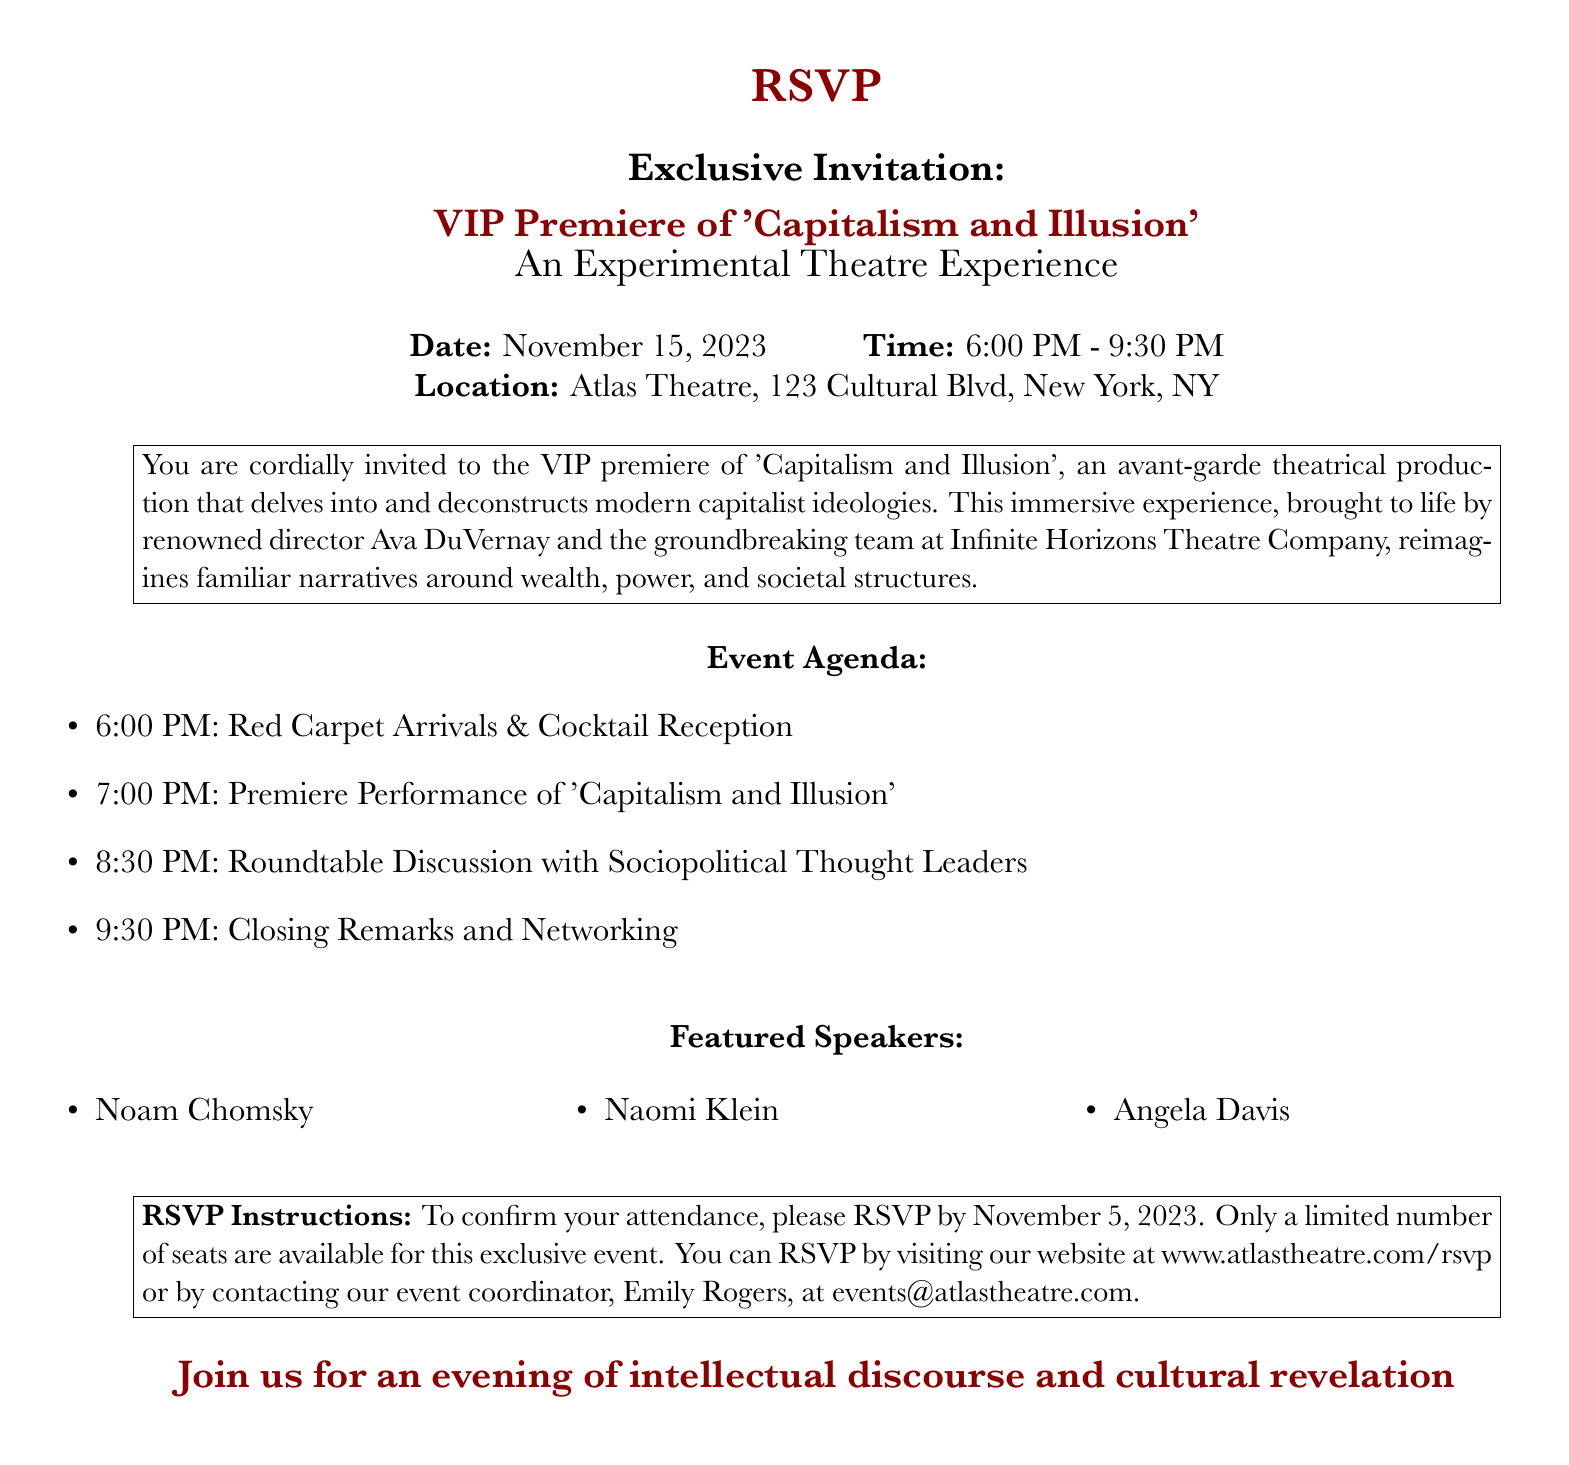What is the date of the event? The date is specified in the document as November 15, 2023.
Answer: November 15, 2023 What time does the premiere performance start? The time for the premiere performance is given as 7:00 PM.
Answer: 7:00 PM Who is the renowned director of the production? The document identifies the director as Ava DuVernay.
Answer: Ava DuVernay What is the location of the event? The location is mentioned as Atlas Theatre, 123 Cultural Blvd, New York, NY.
Answer: Atlas Theatre, 123 Cultural Blvd, New York, NY What kind of event is taking place after the performance? The document states that a roundtable discussion will occur after the performance.
Answer: Roundtable discussion Who are the featured speakers? The document lists Noam Chomsky, Naomi Klein, and Angela Davis as featured speakers.
Answer: Noam Chomsky, Naomi Klein, Angela Davis How can attendees confirm their attendance? Attendees are instructed to visit the website or contact the event coordinator to RSVP.
Answer: Visit the website or contact the event coordinator What is the RSVP deadline? The deadline for RSVP is specified as November 5, 2023.
Answer: November 5, 2023 